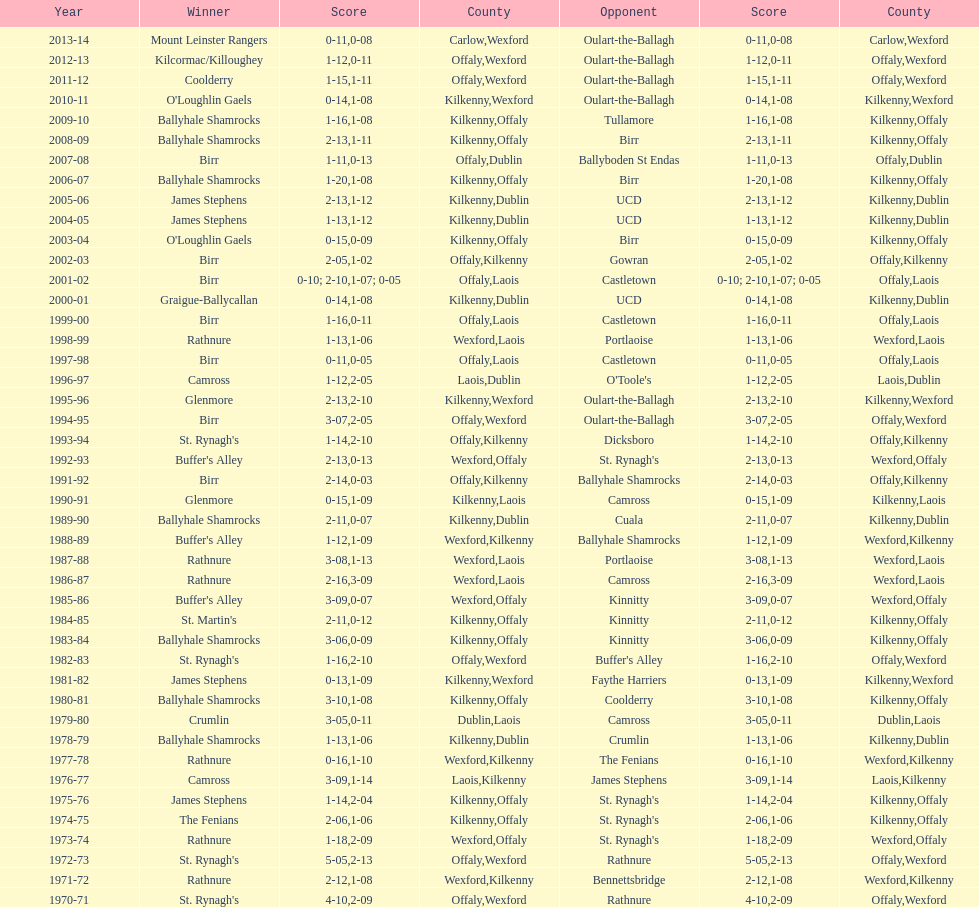What was the last season the leinster senior club hurling championships was won by a score differential of less than 11? 2007-08. 